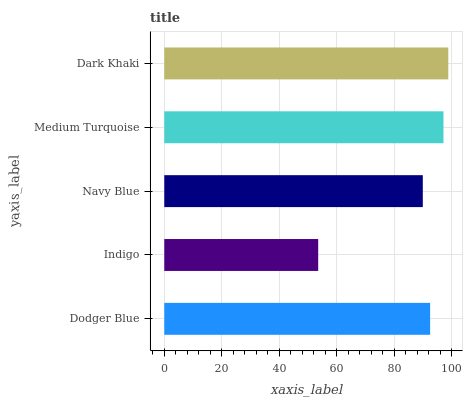Is Indigo the minimum?
Answer yes or no. Yes. Is Dark Khaki the maximum?
Answer yes or no. Yes. Is Navy Blue the minimum?
Answer yes or no. No. Is Navy Blue the maximum?
Answer yes or no. No. Is Navy Blue greater than Indigo?
Answer yes or no. Yes. Is Indigo less than Navy Blue?
Answer yes or no. Yes. Is Indigo greater than Navy Blue?
Answer yes or no. No. Is Navy Blue less than Indigo?
Answer yes or no. No. Is Dodger Blue the high median?
Answer yes or no. Yes. Is Dodger Blue the low median?
Answer yes or no. Yes. Is Medium Turquoise the high median?
Answer yes or no. No. Is Medium Turquoise the low median?
Answer yes or no. No. 